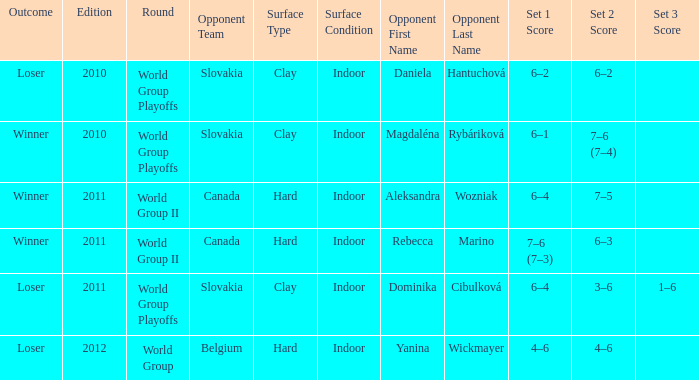What was the score when the opponent was Dominika Cibulková? 6–4, 3–6, 1–6. 